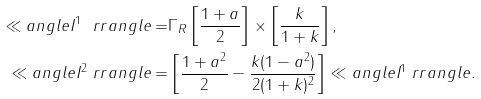Convert formula to latex. <formula><loc_0><loc_0><loc_500><loc_500>\ll a n g l e I ^ { 1 } \ r r a n g l e = & \Gamma _ { R } \left [ \frac { 1 + a } { 2 } \right ] \times \left [ \frac { k } { 1 + k } \right ] , \\ \ll a n g l e I ^ { 2 } \ r r a n g l e = & \left [ \frac { 1 + a ^ { 2 } } { 2 } - \frac { k ( 1 - a ^ { 2 } ) } { 2 ( 1 + k ) ^ { 2 } } \right ] \ll a n g l e I ^ { 1 } \ r r a n g l e .</formula> 